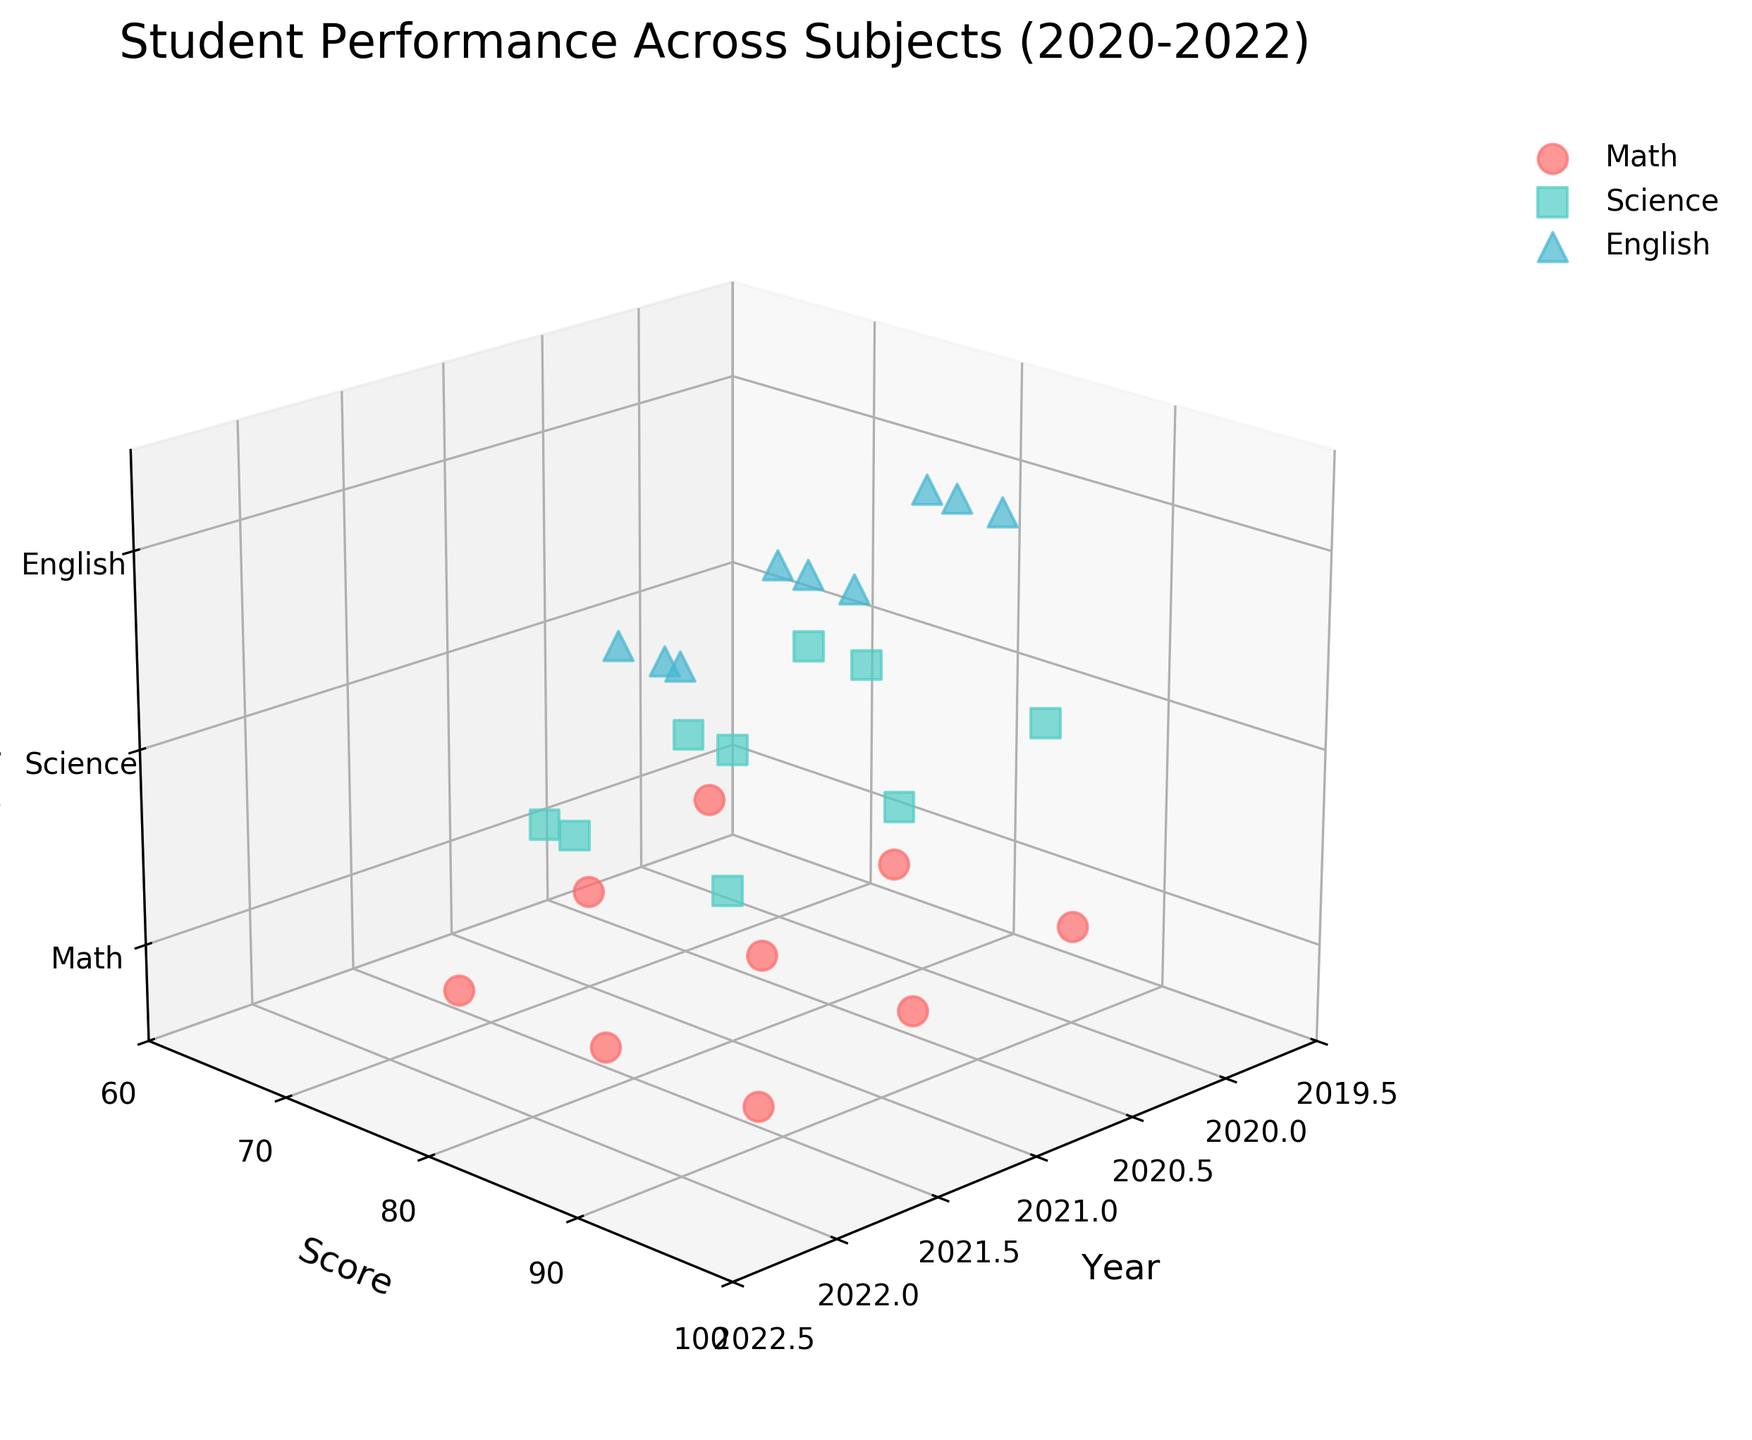What are the years displayed on the x-axis of this 3D scatter plot? The x-axis represents the 'Year' and spans from 2020 to 2022, covering three distinct years.
Answer: 2020, 2021, 2022 What are the subjects represented in this plot? The subjects are displayed on the z-axis and can be identified by the labels and legend in the plot, which include Math, Science, and English.
Answer: Math, Science, English Which subject has the highest score in 2022? By observing the data points for the year 2022, we notice the highest score is visible for the subject Math at 95.
Answer: Math Which subject shows the most consistent increase in scores over the years? By comparing the trend lines for each subject, we observe that all subjects show an increase, but the most consistent increase with small, regular increments can be observed in Science.
Answer: Science What is the score range for English in 2021? The data points for English in 2021 show the scores range from 83 to 88.
Answer: 83 to 88 Is there any subject with a score above 90 in 2020? Observing the data points for each subject in the year 2020, we see that only Math has a score above 90.
Answer: Math Which subject has the maximum average score over the three years? Calculating the average score for each subject over the three years, Math = (78 + 82 + 85 + 65 + 70 + 75 + 90 + 92 + 95) / 9 = 81.78, Science = (76 + 80 + 83 + 72 + 77 + 81 + 88 + 91 + 93) / 9 = 82.33, and English = (85 + 88 + 90 + 80 + 83 + 86 + 82 + 85 + 89) / 9 = 85.33. Therefore, English has the highest average score.
Answer: English How do the scores in Science from 2020 to 2022 compare to those in Math over the same period? By comparing the trends, we see that both subjects exhibit an increasing trend. However, Math starts lower in 2020 and ends higher in 2022 compared to Science, reflecting a steeper increase.
Answer: Math's increase is steeper Which subject had the lowest initial score in 2020 and what was that score? In 2020, the subject with the lowest initial score is Math, with a score of 65.
Answer: Math, 65 